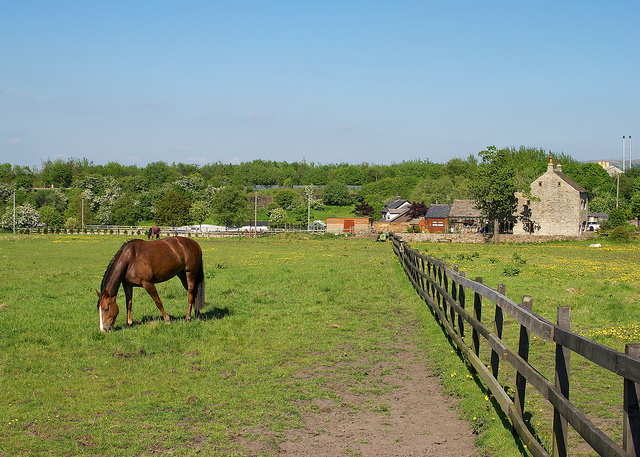Can you tell the season shown in this photo and how does it affect the farm activities? The image suggests it's late spring or early summer, given the vibrant greenery and presence of wildflowers. During this time, farm activities often increase in intensity with tasks such as crop planting, caring for young animals, and preparing hay for winter. The abundant pasture allows animals like the horse pictured to graze extensively, which is beneficial for their health and helps to maintain the grass at an optimal level. 